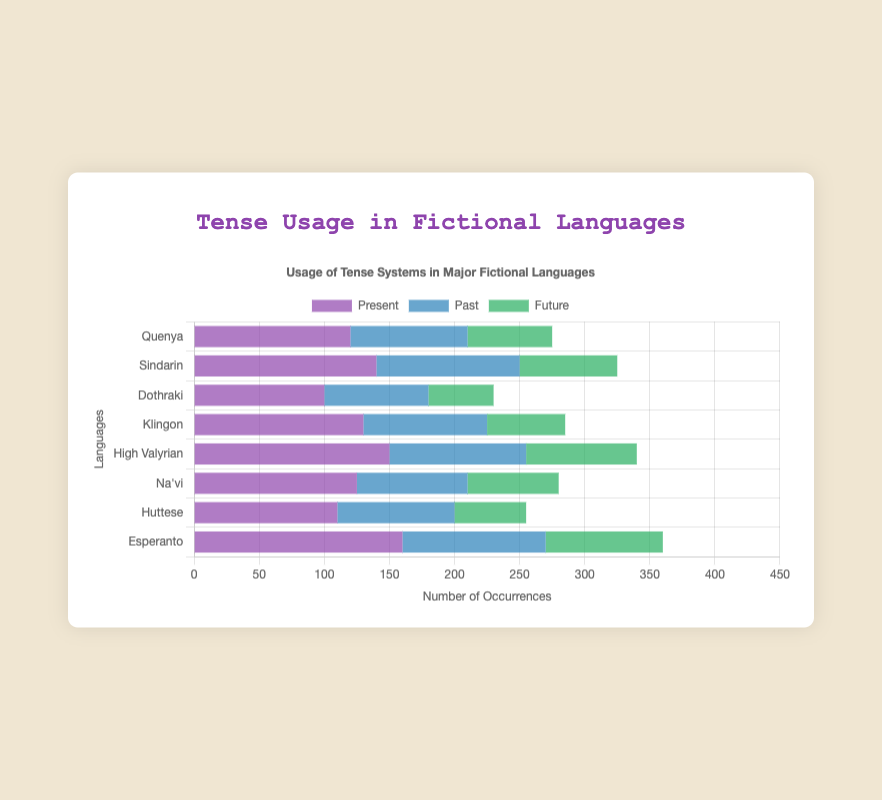What language has the highest overall usage of tenses combined? To find the language with the highest overall usage, we need to sum the present, past, and future tenses for each language. Esperanto has the highest combined total of 360 (160 present + 110 past + 90 future).
Answer: Esperanto Which fictional language uses the future tense the least? By comparing the data for the future tense, we can see that Dothraki has the lowest number of occurrences in the future tense, which is 50.
Answer: Dothraki For which language is the difference between the usage of the past and present tense the highest? The difference for each language is: Quenya (120 - 90 = 30), Sindarin (140 - 110 = 30), Dothraki (100 - 80 = 20), Klingon (130 - 95 = 35), High Valyrian (150 - 105 = 45), Na'vi (125 - 85 = 40), Huttese (110 - 90 = 20), and Esperanto (160 - 110 = 50). The highest difference is for Esperanto with a difference of 50.
Answer: Esperanto What color represents the past tense in the chart? The chart uses a color scheme where each tense is represented by a specific color. Observing the bar colors, the past tense is represented by a blue color.
Answer: Blue How many languages have a higher usage of the present tense compared to the past tense? We count the languages where the usage of the present tense is greater than the past tense: Quenya, Sindarin, Dothraki, Klingon, High Valyrian, Na'vi, Huttese, and Esperanto. All 8 languages have higher usage in the present tense than the past tense.
Answer: 8 Between High Valyrian and Na'vi, which language has more balanced (closer) usage among the three tenses? We compare the differences between the present, past, and future tense usages for both languages. High Valyrian has the values 150 present, 105 past, 85 future, leading to differences of 45 (150 - 105) and 20 (105 - 85). Na'vi has the values 125 present, 85 past, 70 future, with differences of 40 (125 - 85) and 15 (85 - 70). Na'vi shows more balanced usage among the three tenses.
Answer: Na'vi What is the average usage of the past tense across all fictional languages? We sum the occurrences of the past tense across all languages and then divide by the number of languages. The sum is 90 (Quenya) + 110 (Sindarin) + 80 (Dothraki) + 95 (Klingon) + 105 (High Valyrian) + 85 (Na'vi) + 90 (Huttese) + 110 (Esperanto) = 765. There are 8 languages, so the average is 765 / 8 = 95.63.
Answer: 95.63 